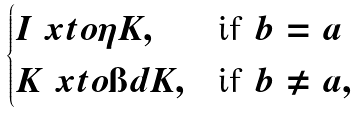<formula> <loc_0><loc_0><loc_500><loc_500>\begin{cases} I \ x t o { \eta } K , & \text {if } b = a \\ K \ x t o { \i d } K , & \text {if } b \neq a , \end{cases}</formula> 